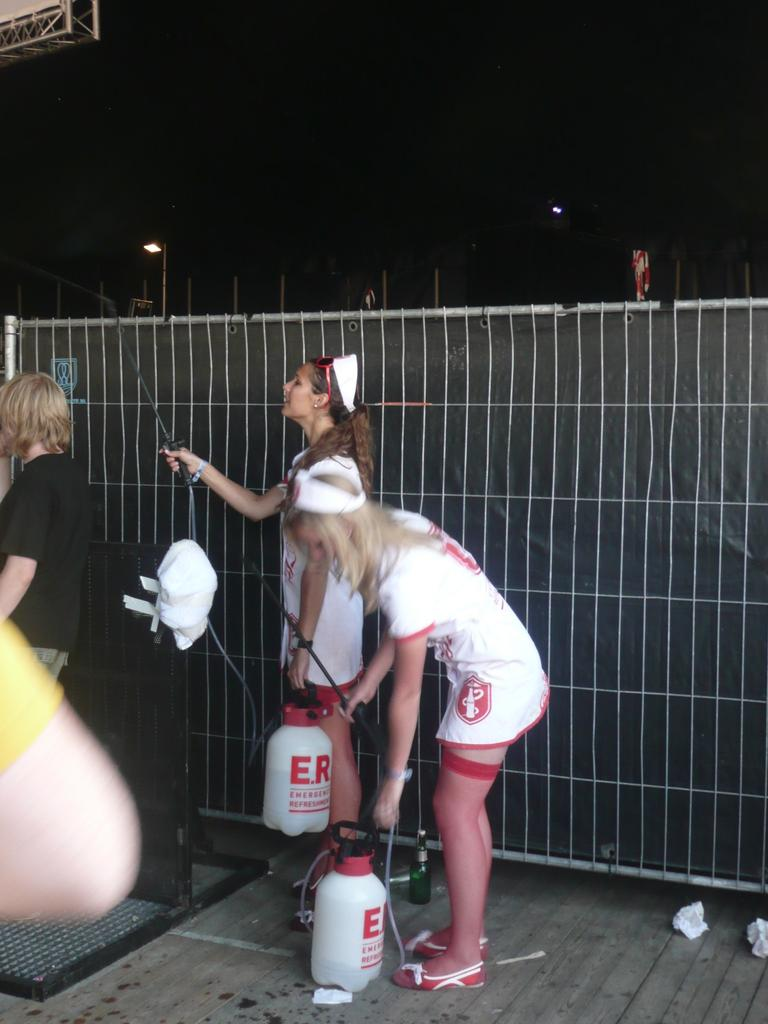<image>
Render a clear and concise summary of the photo. Girls in nurse uniforms with spray container with E.R. in red lettering. 